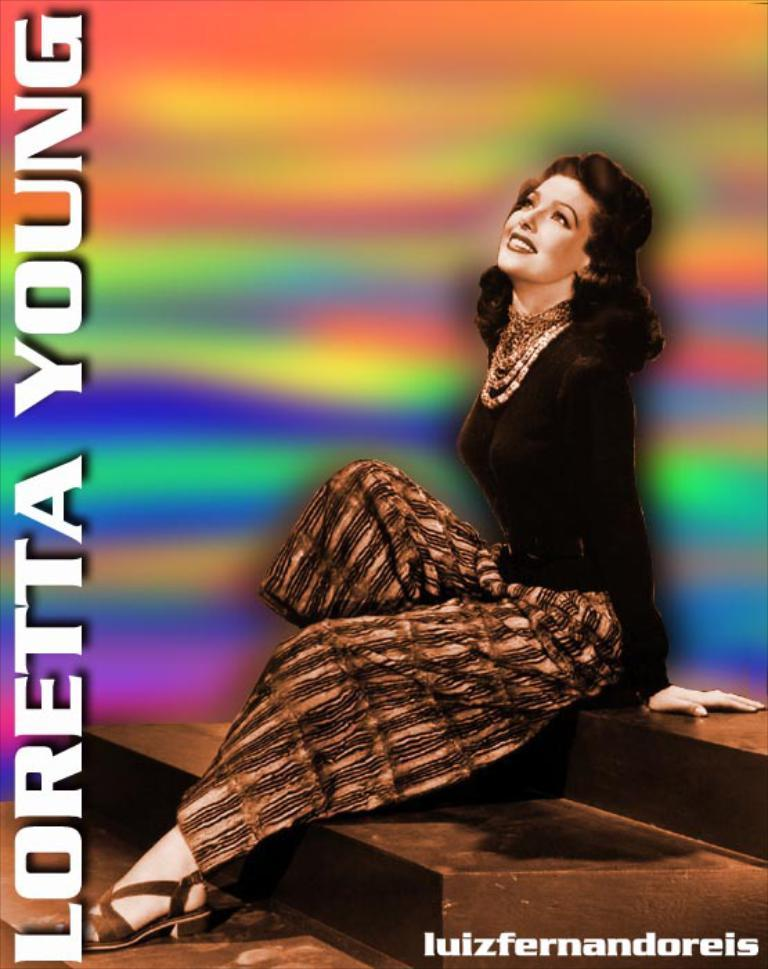What is featured in the image? There is a poster in the image. What is the main image on the poster? The poster depicts a person sitting on stairs. Are there any words on the poster? Yes, there is text written on the poster. What type of company is shown operating the engine in the image? There is no company or engine present in the image; it only features a poster with a person sitting on stairs and text. 